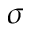<formula> <loc_0><loc_0><loc_500><loc_500>\sigma</formula> 